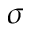<formula> <loc_0><loc_0><loc_500><loc_500>\sigma</formula> 